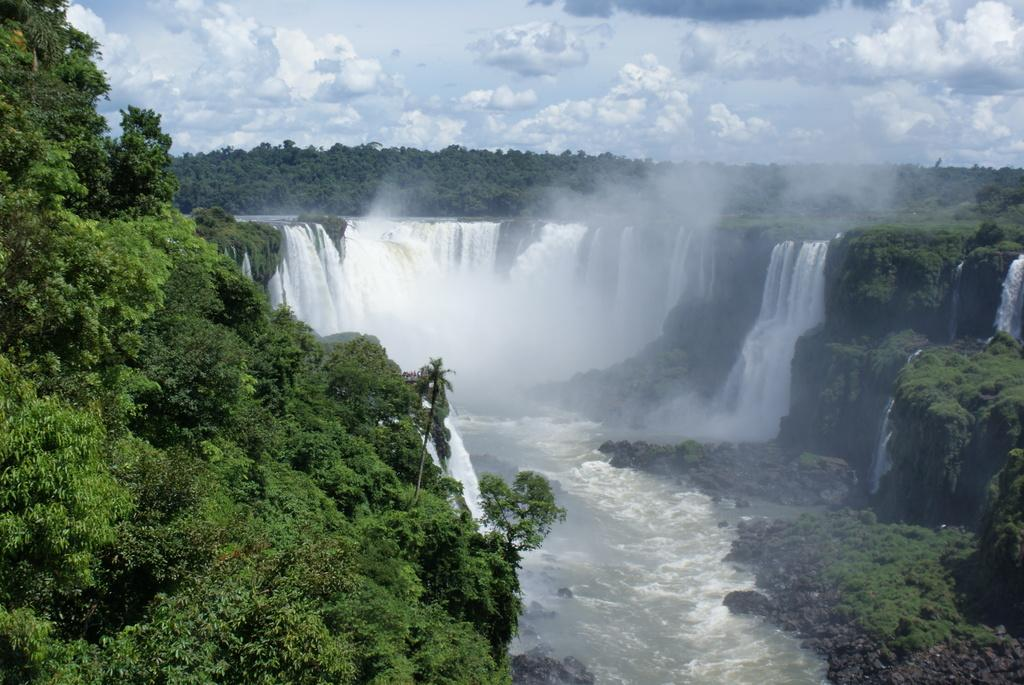What type of vegetation can be seen in the image? There are trees in the image. What natural element is visible in the image besides the trees? There is water visible in the image. What can be seen in the sky in the background of the image? There are clouds in the background of the image. What type of tail can be seen on the trees in the image? There are no tails present on the trees in the image, as trees do not have tails. 